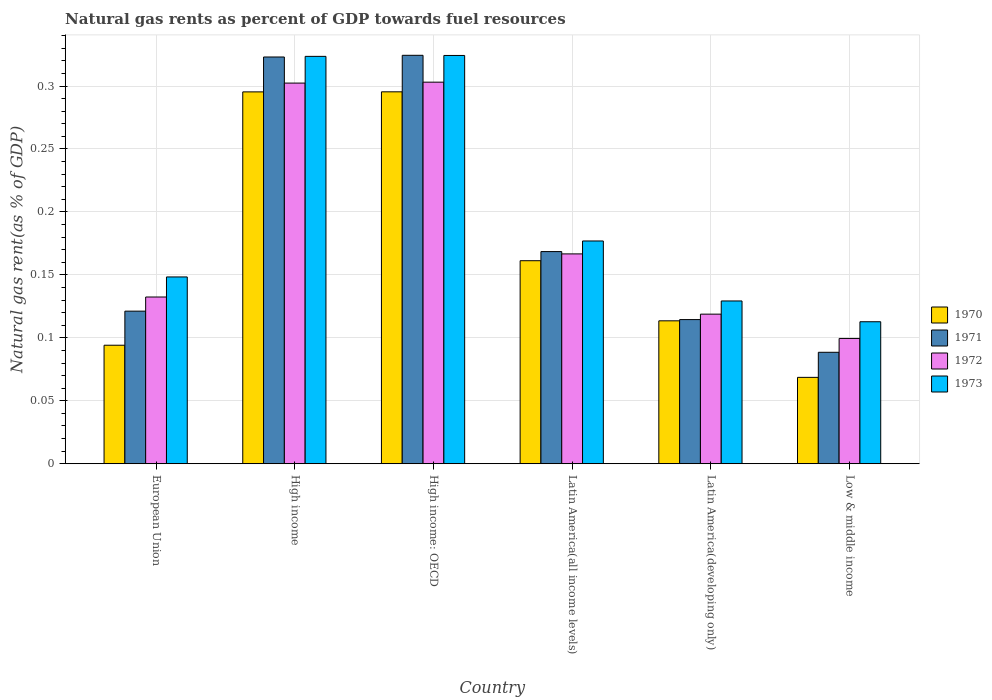How many different coloured bars are there?
Your answer should be very brief. 4. Are the number of bars per tick equal to the number of legend labels?
Provide a succinct answer. Yes. How many bars are there on the 5th tick from the right?
Make the answer very short. 4. In how many cases, is the number of bars for a given country not equal to the number of legend labels?
Offer a terse response. 0. What is the natural gas rent in 1970 in Latin America(all income levels)?
Your answer should be compact. 0.16. Across all countries, what is the maximum natural gas rent in 1971?
Give a very brief answer. 0.32. Across all countries, what is the minimum natural gas rent in 1971?
Your response must be concise. 0.09. In which country was the natural gas rent in 1973 maximum?
Give a very brief answer. High income: OECD. What is the total natural gas rent in 1970 in the graph?
Offer a terse response. 1.03. What is the difference between the natural gas rent in 1971 in Latin America(all income levels) and that in Low & middle income?
Ensure brevity in your answer.  0.08. What is the difference between the natural gas rent in 1972 in Latin America(all income levels) and the natural gas rent in 1973 in European Union?
Your response must be concise. 0.02. What is the average natural gas rent in 1971 per country?
Your response must be concise. 0.19. What is the difference between the natural gas rent of/in 1970 and natural gas rent of/in 1971 in Low & middle income?
Offer a terse response. -0.02. In how many countries, is the natural gas rent in 1971 greater than 0.17 %?
Your response must be concise. 2. What is the ratio of the natural gas rent in 1971 in European Union to that in Latin America(all income levels)?
Offer a terse response. 0.72. Is the difference between the natural gas rent in 1970 in High income: OECD and Latin America(developing only) greater than the difference between the natural gas rent in 1971 in High income: OECD and Latin America(developing only)?
Your answer should be very brief. No. What is the difference between the highest and the second highest natural gas rent in 1972?
Keep it short and to the point. 0. What is the difference between the highest and the lowest natural gas rent in 1973?
Provide a short and direct response. 0.21. In how many countries, is the natural gas rent in 1970 greater than the average natural gas rent in 1970 taken over all countries?
Ensure brevity in your answer.  2. Is it the case that in every country, the sum of the natural gas rent in 1973 and natural gas rent in 1970 is greater than the sum of natural gas rent in 1972 and natural gas rent in 1971?
Your response must be concise. No. What does the 2nd bar from the left in Latin America(all income levels) represents?
Provide a succinct answer. 1971. Is it the case that in every country, the sum of the natural gas rent in 1973 and natural gas rent in 1970 is greater than the natural gas rent in 1971?
Ensure brevity in your answer.  Yes. How many bars are there?
Ensure brevity in your answer.  24. How many countries are there in the graph?
Offer a terse response. 6. What is the difference between two consecutive major ticks on the Y-axis?
Provide a succinct answer. 0.05. Does the graph contain any zero values?
Provide a succinct answer. No. Does the graph contain grids?
Your answer should be compact. Yes. How are the legend labels stacked?
Your answer should be very brief. Vertical. What is the title of the graph?
Provide a succinct answer. Natural gas rents as percent of GDP towards fuel resources. Does "1967" appear as one of the legend labels in the graph?
Give a very brief answer. No. What is the label or title of the X-axis?
Your response must be concise. Country. What is the label or title of the Y-axis?
Offer a very short reply. Natural gas rent(as % of GDP). What is the Natural gas rent(as % of GDP) in 1970 in European Union?
Provide a short and direct response. 0.09. What is the Natural gas rent(as % of GDP) of 1971 in European Union?
Ensure brevity in your answer.  0.12. What is the Natural gas rent(as % of GDP) in 1972 in European Union?
Provide a short and direct response. 0.13. What is the Natural gas rent(as % of GDP) of 1973 in European Union?
Give a very brief answer. 0.15. What is the Natural gas rent(as % of GDP) of 1970 in High income?
Your answer should be very brief. 0.3. What is the Natural gas rent(as % of GDP) of 1971 in High income?
Offer a terse response. 0.32. What is the Natural gas rent(as % of GDP) in 1972 in High income?
Provide a short and direct response. 0.3. What is the Natural gas rent(as % of GDP) of 1973 in High income?
Offer a very short reply. 0.32. What is the Natural gas rent(as % of GDP) of 1970 in High income: OECD?
Offer a very short reply. 0.3. What is the Natural gas rent(as % of GDP) of 1971 in High income: OECD?
Provide a succinct answer. 0.32. What is the Natural gas rent(as % of GDP) in 1972 in High income: OECD?
Provide a succinct answer. 0.3. What is the Natural gas rent(as % of GDP) of 1973 in High income: OECD?
Your response must be concise. 0.32. What is the Natural gas rent(as % of GDP) in 1970 in Latin America(all income levels)?
Provide a succinct answer. 0.16. What is the Natural gas rent(as % of GDP) of 1971 in Latin America(all income levels)?
Your answer should be compact. 0.17. What is the Natural gas rent(as % of GDP) in 1972 in Latin America(all income levels)?
Keep it short and to the point. 0.17. What is the Natural gas rent(as % of GDP) of 1973 in Latin America(all income levels)?
Your answer should be compact. 0.18. What is the Natural gas rent(as % of GDP) in 1970 in Latin America(developing only)?
Offer a very short reply. 0.11. What is the Natural gas rent(as % of GDP) of 1971 in Latin America(developing only)?
Offer a very short reply. 0.11. What is the Natural gas rent(as % of GDP) in 1972 in Latin America(developing only)?
Offer a terse response. 0.12. What is the Natural gas rent(as % of GDP) in 1973 in Latin America(developing only)?
Provide a short and direct response. 0.13. What is the Natural gas rent(as % of GDP) of 1970 in Low & middle income?
Your response must be concise. 0.07. What is the Natural gas rent(as % of GDP) in 1971 in Low & middle income?
Make the answer very short. 0.09. What is the Natural gas rent(as % of GDP) of 1972 in Low & middle income?
Ensure brevity in your answer.  0.1. What is the Natural gas rent(as % of GDP) of 1973 in Low & middle income?
Provide a short and direct response. 0.11. Across all countries, what is the maximum Natural gas rent(as % of GDP) in 1970?
Offer a very short reply. 0.3. Across all countries, what is the maximum Natural gas rent(as % of GDP) in 1971?
Your answer should be very brief. 0.32. Across all countries, what is the maximum Natural gas rent(as % of GDP) in 1972?
Ensure brevity in your answer.  0.3. Across all countries, what is the maximum Natural gas rent(as % of GDP) in 1973?
Give a very brief answer. 0.32. Across all countries, what is the minimum Natural gas rent(as % of GDP) of 1970?
Provide a succinct answer. 0.07. Across all countries, what is the minimum Natural gas rent(as % of GDP) of 1971?
Your response must be concise. 0.09. Across all countries, what is the minimum Natural gas rent(as % of GDP) in 1972?
Offer a terse response. 0.1. Across all countries, what is the minimum Natural gas rent(as % of GDP) in 1973?
Give a very brief answer. 0.11. What is the total Natural gas rent(as % of GDP) of 1970 in the graph?
Provide a short and direct response. 1.03. What is the total Natural gas rent(as % of GDP) in 1971 in the graph?
Provide a short and direct response. 1.14. What is the total Natural gas rent(as % of GDP) in 1972 in the graph?
Keep it short and to the point. 1.12. What is the total Natural gas rent(as % of GDP) of 1973 in the graph?
Ensure brevity in your answer.  1.22. What is the difference between the Natural gas rent(as % of GDP) in 1970 in European Union and that in High income?
Ensure brevity in your answer.  -0.2. What is the difference between the Natural gas rent(as % of GDP) in 1971 in European Union and that in High income?
Provide a short and direct response. -0.2. What is the difference between the Natural gas rent(as % of GDP) of 1972 in European Union and that in High income?
Your response must be concise. -0.17. What is the difference between the Natural gas rent(as % of GDP) of 1973 in European Union and that in High income?
Make the answer very short. -0.18. What is the difference between the Natural gas rent(as % of GDP) of 1970 in European Union and that in High income: OECD?
Provide a succinct answer. -0.2. What is the difference between the Natural gas rent(as % of GDP) of 1971 in European Union and that in High income: OECD?
Provide a short and direct response. -0.2. What is the difference between the Natural gas rent(as % of GDP) of 1972 in European Union and that in High income: OECD?
Offer a terse response. -0.17. What is the difference between the Natural gas rent(as % of GDP) of 1973 in European Union and that in High income: OECD?
Your response must be concise. -0.18. What is the difference between the Natural gas rent(as % of GDP) of 1970 in European Union and that in Latin America(all income levels)?
Provide a short and direct response. -0.07. What is the difference between the Natural gas rent(as % of GDP) of 1971 in European Union and that in Latin America(all income levels)?
Provide a short and direct response. -0.05. What is the difference between the Natural gas rent(as % of GDP) of 1972 in European Union and that in Latin America(all income levels)?
Provide a short and direct response. -0.03. What is the difference between the Natural gas rent(as % of GDP) in 1973 in European Union and that in Latin America(all income levels)?
Your answer should be very brief. -0.03. What is the difference between the Natural gas rent(as % of GDP) in 1970 in European Union and that in Latin America(developing only)?
Provide a short and direct response. -0.02. What is the difference between the Natural gas rent(as % of GDP) in 1971 in European Union and that in Latin America(developing only)?
Keep it short and to the point. 0.01. What is the difference between the Natural gas rent(as % of GDP) in 1972 in European Union and that in Latin America(developing only)?
Your answer should be compact. 0.01. What is the difference between the Natural gas rent(as % of GDP) in 1973 in European Union and that in Latin America(developing only)?
Your answer should be compact. 0.02. What is the difference between the Natural gas rent(as % of GDP) of 1970 in European Union and that in Low & middle income?
Your response must be concise. 0.03. What is the difference between the Natural gas rent(as % of GDP) in 1971 in European Union and that in Low & middle income?
Make the answer very short. 0.03. What is the difference between the Natural gas rent(as % of GDP) of 1972 in European Union and that in Low & middle income?
Your response must be concise. 0.03. What is the difference between the Natural gas rent(as % of GDP) in 1973 in European Union and that in Low & middle income?
Provide a succinct answer. 0.04. What is the difference between the Natural gas rent(as % of GDP) in 1970 in High income and that in High income: OECD?
Keep it short and to the point. -0. What is the difference between the Natural gas rent(as % of GDP) of 1971 in High income and that in High income: OECD?
Your response must be concise. -0. What is the difference between the Natural gas rent(as % of GDP) in 1972 in High income and that in High income: OECD?
Ensure brevity in your answer.  -0. What is the difference between the Natural gas rent(as % of GDP) in 1973 in High income and that in High income: OECD?
Your response must be concise. -0. What is the difference between the Natural gas rent(as % of GDP) in 1970 in High income and that in Latin America(all income levels)?
Provide a short and direct response. 0.13. What is the difference between the Natural gas rent(as % of GDP) of 1971 in High income and that in Latin America(all income levels)?
Keep it short and to the point. 0.15. What is the difference between the Natural gas rent(as % of GDP) in 1972 in High income and that in Latin America(all income levels)?
Offer a very short reply. 0.14. What is the difference between the Natural gas rent(as % of GDP) in 1973 in High income and that in Latin America(all income levels)?
Offer a very short reply. 0.15. What is the difference between the Natural gas rent(as % of GDP) in 1970 in High income and that in Latin America(developing only)?
Ensure brevity in your answer.  0.18. What is the difference between the Natural gas rent(as % of GDP) of 1971 in High income and that in Latin America(developing only)?
Keep it short and to the point. 0.21. What is the difference between the Natural gas rent(as % of GDP) in 1972 in High income and that in Latin America(developing only)?
Provide a short and direct response. 0.18. What is the difference between the Natural gas rent(as % of GDP) of 1973 in High income and that in Latin America(developing only)?
Keep it short and to the point. 0.19. What is the difference between the Natural gas rent(as % of GDP) of 1970 in High income and that in Low & middle income?
Your answer should be very brief. 0.23. What is the difference between the Natural gas rent(as % of GDP) in 1971 in High income and that in Low & middle income?
Your answer should be compact. 0.23. What is the difference between the Natural gas rent(as % of GDP) in 1972 in High income and that in Low & middle income?
Your answer should be compact. 0.2. What is the difference between the Natural gas rent(as % of GDP) of 1973 in High income and that in Low & middle income?
Your answer should be very brief. 0.21. What is the difference between the Natural gas rent(as % of GDP) of 1970 in High income: OECD and that in Latin America(all income levels)?
Your answer should be compact. 0.13. What is the difference between the Natural gas rent(as % of GDP) in 1971 in High income: OECD and that in Latin America(all income levels)?
Make the answer very short. 0.16. What is the difference between the Natural gas rent(as % of GDP) in 1972 in High income: OECD and that in Latin America(all income levels)?
Keep it short and to the point. 0.14. What is the difference between the Natural gas rent(as % of GDP) in 1973 in High income: OECD and that in Latin America(all income levels)?
Your answer should be very brief. 0.15. What is the difference between the Natural gas rent(as % of GDP) of 1970 in High income: OECD and that in Latin America(developing only)?
Provide a short and direct response. 0.18. What is the difference between the Natural gas rent(as % of GDP) in 1971 in High income: OECD and that in Latin America(developing only)?
Offer a very short reply. 0.21. What is the difference between the Natural gas rent(as % of GDP) of 1972 in High income: OECD and that in Latin America(developing only)?
Make the answer very short. 0.18. What is the difference between the Natural gas rent(as % of GDP) of 1973 in High income: OECD and that in Latin America(developing only)?
Your answer should be very brief. 0.2. What is the difference between the Natural gas rent(as % of GDP) of 1970 in High income: OECD and that in Low & middle income?
Make the answer very short. 0.23. What is the difference between the Natural gas rent(as % of GDP) in 1971 in High income: OECD and that in Low & middle income?
Give a very brief answer. 0.24. What is the difference between the Natural gas rent(as % of GDP) in 1972 in High income: OECD and that in Low & middle income?
Offer a terse response. 0.2. What is the difference between the Natural gas rent(as % of GDP) of 1973 in High income: OECD and that in Low & middle income?
Your answer should be very brief. 0.21. What is the difference between the Natural gas rent(as % of GDP) in 1970 in Latin America(all income levels) and that in Latin America(developing only)?
Ensure brevity in your answer.  0.05. What is the difference between the Natural gas rent(as % of GDP) in 1971 in Latin America(all income levels) and that in Latin America(developing only)?
Ensure brevity in your answer.  0.05. What is the difference between the Natural gas rent(as % of GDP) in 1972 in Latin America(all income levels) and that in Latin America(developing only)?
Make the answer very short. 0.05. What is the difference between the Natural gas rent(as % of GDP) in 1973 in Latin America(all income levels) and that in Latin America(developing only)?
Your answer should be very brief. 0.05. What is the difference between the Natural gas rent(as % of GDP) of 1970 in Latin America(all income levels) and that in Low & middle income?
Offer a terse response. 0.09. What is the difference between the Natural gas rent(as % of GDP) of 1971 in Latin America(all income levels) and that in Low & middle income?
Offer a terse response. 0.08. What is the difference between the Natural gas rent(as % of GDP) of 1972 in Latin America(all income levels) and that in Low & middle income?
Your answer should be very brief. 0.07. What is the difference between the Natural gas rent(as % of GDP) of 1973 in Latin America(all income levels) and that in Low & middle income?
Provide a short and direct response. 0.06. What is the difference between the Natural gas rent(as % of GDP) in 1970 in Latin America(developing only) and that in Low & middle income?
Provide a short and direct response. 0.04. What is the difference between the Natural gas rent(as % of GDP) of 1971 in Latin America(developing only) and that in Low & middle income?
Your answer should be very brief. 0.03. What is the difference between the Natural gas rent(as % of GDP) of 1972 in Latin America(developing only) and that in Low & middle income?
Make the answer very short. 0.02. What is the difference between the Natural gas rent(as % of GDP) of 1973 in Latin America(developing only) and that in Low & middle income?
Give a very brief answer. 0.02. What is the difference between the Natural gas rent(as % of GDP) in 1970 in European Union and the Natural gas rent(as % of GDP) in 1971 in High income?
Keep it short and to the point. -0.23. What is the difference between the Natural gas rent(as % of GDP) of 1970 in European Union and the Natural gas rent(as % of GDP) of 1972 in High income?
Your answer should be compact. -0.21. What is the difference between the Natural gas rent(as % of GDP) in 1970 in European Union and the Natural gas rent(as % of GDP) in 1973 in High income?
Give a very brief answer. -0.23. What is the difference between the Natural gas rent(as % of GDP) in 1971 in European Union and the Natural gas rent(as % of GDP) in 1972 in High income?
Provide a succinct answer. -0.18. What is the difference between the Natural gas rent(as % of GDP) in 1971 in European Union and the Natural gas rent(as % of GDP) in 1973 in High income?
Ensure brevity in your answer.  -0.2. What is the difference between the Natural gas rent(as % of GDP) in 1972 in European Union and the Natural gas rent(as % of GDP) in 1973 in High income?
Make the answer very short. -0.19. What is the difference between the Natural gas rent(as % of GDP) of 1970 in European Union and the Natural gas rent(as % of GDP) of 1971 in High income: OECD?
Keep it short and to the point. -0.23. What is the difference between the Natural gas rent(as % of GDP) of 1970 in European Union and the Natural gas rent(as % of GDP) of 1972 in High income: OECD?
Your answer should be very brief. -0.21. What is the difference between the Natural gas rent(as % of GDP) in 1970 in European Union and the Natural gas rent(as % of GDP) in 1973 in High income: OECD?
Provide a short and direct response. -0.23. What is the difference between the Natural gas rent(as % of GDP) in 1971 in European Union and the Natural gas rent(as % of GDP) in 1972 in High income: OECD?
Ensure brevity in your answer.  -0.18. What is the difference between the Natural gas rent(as % of GDP) in 1971 in European Union and the Natural gas rent(as % of GDP) in 1973 in High income: OECD?
Offer a very short reply. -0.2. What is the difference between the Natural gas rent(as % of GDP) in 1972 in European Union and the Natural gas rent(as % of GDP) in 1973 in High income: OECD?
Give a very brief answer. -0.19. What is the difference between the Natural gas rent(as % of GDP) of 1970 in European Union and the Natural gas rent(as % of GDP) of 1971 in Latin America(all income levels)?
Offer a terse response. -0.07. What is the difference between the Natural gas rent(as % of GDP) of 1970 in European Union and the Natural gas rent(as % of GDP) of 1972 in Latin America(all income levels)?
Offer a very short reply. -0.07. What is the difference between the Natural gas rent(as % of GDP) of 1970 in European Union and the Natural gas rent(as % of GDP) of 1973 in Latin America(all income levels)?
Ensure brevity in your answer.  -0.08. What is the difference between the Natural gas rent(as % of GDP) in 1971 in European Union and the Natural gas rent(as % of GDP) in 1972 in Latin America(all income levels)?
Your answer should be very brief. -0.05. What is the difference between the Natural gas rent(as % of GDP) in 1971 in European Union and the Natural gas rent(as % of GDP) in 1973 in Latin America(all income levels)?
Your answer should be compact. -0.06. What is the difference between the Natural gas rent(as % of GDP) in 1972 in European Union and the Natural gas rent(as % of GDP) in 1973 in Latin America(all income levels)?
Provide a succinct answer. -0.04. What is the difference between the Natural gas rent(as % of GDP) of 1970 in European Union and the Natural gas rent(as % of GDP) of 1971 in Latin America(developing only)?
Provide a succinct answer. -0.02. What is the difference between the Natural gas rent(as % of GDP) of 1970 in European Union and the Natural gas rent(as % of GDP) of 1972 in Latin America(developing only)?
Your answer should be compact. -0.02. What is the difference between the Natural gas rent(as % of GDP) of 1970 in European Union and the Natural gas rent(as % of GDP) of 1973 in Latin America(developing only)?
Ensure brevity in your answer.  -0.04. What is the difference between the Natural gas rent(as % of GDP) in 1971 in European Union and the Natural gas rent(as % of GDP) in 1972 in Latin America(developing only)?
Offer a terse response. 0. What is the difference between the Natural gas rent(as % of GDP) in 1971 in European Union and the Natural gas rent(as % of GDP) in 1973 in Latin America(developing only)?
Give a very brief answer. -0.01. What is the difference between the Natural gas rent(as % of GDP) of 1972 in European Union and the Natural gas rent(as % of GDP) of 1973 in Latin America(developing only)?
Make the answer very short. 0. What is the difference between the Natural gas rent(as % of GDP) in 1970 in European Union and the Natural gas rent(as % of GDP) in 1971 in Low & middle income?
Give a very brief answer. 0.01. What is the difference between the Natural gas rent(as % of GDP) of 1970 in European Union and the Natural gas rent(as % of GDP) of 1972 in Low & middle income?
Provide a short and direct response. -0.01. What is the difference between the Natural gas rent(as % of GDP) of 1970 in European Union and the Natural gas rent(as % of GDP) of 1973 in Low & middle income?
Offer a very short reply. -0.02. What is the difference between the Natural gas rent(as % of GDP) of 1971 in European Union and the Natural gas rent(as % of GDP) of 1972 in Low & middle income?
Give a very brief answer. 0.02. What is the difference between the Natural gas rent(as % of GDP) in 1971 in European Union and the Natural gas rent(as % of GDP) in 1973 in Low & middle income?
Offer a very short reply. 0.01. What is the difference between the Natural gas rent(as % of GDP) in 1972 in European Union and the Natural gas rent(as % of GDP) in 1973 in Low & middle income?
Offer a terse response. 0.02. What is the difference between the Natural gas rent(as % of GDP) in 1970 in High income and the Natural gas rent(as % of GDP) in 1971 in High income: OECD?
Your answer should be compact. -0.03. What is the difference between the Natural gas rent(as % of GDP) of 1970 in High income and the Natural gas rent(as % of GDP) of 1972 in High income: OECD?
Give a very brief answer. -0.01. What is the difference between the Natural gas rent(as % of GDP) of 1970 in High income and the Natural gas rent(as % of GDP) of 1973 in High income: OECD?
Your answer should be compact. -0.03. What is the difference between the Natural gas rent(as % of GDP) in 1971 in High income and the Natural gas rent(as % of GDP) in 1973 in High income: OECD?
Offer a terse response. -0. What is the difference between the Natural gas rent(as % of GDP) of 1972 in High income and the Natural gas rent(as % of GDP) of 1973 in High income: OECD?
Keep it short and to the point. -0.02. What is the difference between the Natural gas rent(as % of GDP) of 1970 in High income and the Natural gas rent(as % of GDP) of 1971 in Latin America(all income levels)?
Offer a very short reply. 0.13. What is the difference between the Natural gas rent(as % of GDP) in 1970 in High income and the Natural gas rent(as % of GDP) in 1972 in Latin America(all income levels)?
Provide a short and direct response. 0.13. What is the difference between the Natural gas rent(as % of GDP) in 1970 in High income and the Natural gas rent(as % of GDP) in 1973 in Latin America(all income levels)?
Make the answer very short. 0.12. What is the difference between the Natural gas rent(as % of GDP) in 1971 in High income and the Natural gas rent(as % of GDP) in 1972 in Latin America(all income levels)?
Ensure brevity in your answer.  0.16. What is the difference between the Natural gas rent(as % of GDP) in 1971 in High income and the Natural gas rent(as % of GDP) in 1973 in Latin America(all income levels)?
Give a very brief answer. 0.15. What is the difference between the Natural gas rent(as % of GDP) in 1972 in High income and the Natural gas rent(as % of GDP) in 1973 in Latin America(all income levels)?
Give a very brief answer. 0.13. What is the difference between the Natural gas rent(as % of GDP) of 1970 in High income and the Natural gas rent(as % of GDP) of 1971 in Latin America(developing only)?
Give a very brief answer. 0.18. What is the difference between the Natural gas rent(as % of GDP) of 1970 in High income and the Natural gas rent(as % of GDP) of 1972 in Latin America(developing only)?
Provide a succinct answer. 0.18. What is the difference between the Natural gas rent(as % of GDP) in 1970 in High income and the Natural gas rent(as % of GDP) in 1973 in Latin America(developing only)?
Provide a short and direct response. 0.17. What is the difference between the Natural gas rent(as % of GDP) in 1971 in High income and the Natural gas rent(as % of GDP) in 1972 in Latin America(developing only)?
Keep it short and to the point. 0.2. What is the difference between the Natural gas rent(as % of GDP) in 1971 in High income and the Natural gas rent(as % of GDP) in 1973 in Latin America(developing only)?
Your response must be concise. 0.19. What is the difference between the Natural gas rent(as % of GDP) in 1972 in High income and the Natural gas rent(as % of GDP) in 1973 in Latin America(developing only)?
Ensure brevity in your answer.  0.17. What is the difference between the Natural gas rent(as % of GDP) in 1970 in High income and the Natural gas rent(as % of GDP) in 1971 in Low & middle income?
Your answer should be compact. 0.21. What is the difference between the Natural gas rent(as % of GDP) of 1970 in High income and the Natural gas rent(as % of GDP) of 1972 in Low & middle income?
Ensure brevity in your answer.  0.2. What is the difference between the Natural gas rent(as % of GDP) in 1970 in High income and the Natural gas rent(as % of GDP) in 1973 in Low & middle income?
Provide a succinct answer. 0.18. What is the difference between the Natural gas rent(as % of GDP) of 1971 in High income and the Natural gas rent(as % of GDP) of 1972 in Low & middle income?
Your response must be concise. 0.22. What is the difference between the Natural gas rent(as % of GDP) in 1971 in High income and the Natural gas rent(as % of GDP) in 1973 in Low & middle income?
Your answer should be very brief. 0.21. What is the difference between the Natural gas rent(as % of GDP) in 1972 in High income and the Natural gas rent(as % of GDP) in 1973 in Low & middle income?
Give a very brief answer. 0.19. What is the difference between the Natural gas rent(as % of GDP) of 1970 in High income: OECD and the Natural gas rent(as % of GDP) of 1971 in Latin America(all income levels)?
Offer a very short reply. 0.13. What is the difference between the Natural gas rent(as % of GDP) in 1970 in High income: OECD and the Natural gas rent(as % of GDP) in 1972 in Latin America(all income levels)?
Keep it short and to the point. 0.13. What is the difference between the Natural gas rent(as % of GDP) of 1970 in High income: OECD and the Natural gas rent(as % of GDP) of 1973 in Latin America(all income levels)?
Offer a terse response. 0.12. What is the difference between the Natural gas rent(as % of GDP) of 1971 in High income: OECD and the Natural gas rent(as % of GDP) of 1972 in Latin America(all income levels)?
Offer a very short reply. 0.16. What is the difference between the Natural gas rent(as % of GDP) of 1971 in High income: OECD and the Natural gas rent(as % of GDP) of 1973 in Latin America(all income levels)?
Keep it short and to the point. 0.15. What is the difference between the Natural gas rent(as % of GDP) of 1972 in High income: OECD and the Natural gas rent(as % of GDP) of 1973 in Latin America(all income levels)?
Your answer should be very brief. 0.13. What is the difference between the Natural gas rent(as % of GDP) of 1970 in High income: OECD and the Natural gas rent(as % of GDP) of 1971 in Latin America(developing only)?
Provide a succinct answer. 0.18. What is the difference between the Natural gas rent(as % of GDP) in 1970 in High income: OECD and the Natural gas rent(as % of GDP) in 1972 in Latin America(developing only)?
Keep it short and to the point. 0.18. What is the difference between the Natural gas rent(as % of GDP) of 1970 in High income: OECD and the Natural gas rent(as % of GDP) of 1973 in Latin America(developing only)?
Your answer should be compact. 0.17. What is the difference between the Natural gas rent(as % of GDP) in 1971 in High income: OECD and the Natural gas rent(as % of GDP) in 1972 in Latin America(developing only)?
Your answer should be very brief. 0.21. What is the difference between the Natural gas rent(as % of GDP) in 1971 in High income: OECD and the Natural gas rent(as % of GDP) in 1973 in Latin America(developing only)?
Provide a short and direct response. 0.2. What is the difference between the Natural gas rent(as % of GDP) in 1972 in High income: OECD and the Natural gas rent(as % of GDP) in 1973 in Latin America(developing only)?
Offer a terse response. 0.17. What is the difference between the Natural gas rent(as % of GDP) in 1970 in High income: OECD and the Natural gas rent(as % of GDP) in 1971 in Low & middle income?
Offer a very short reply. 0.21. What is the difference between the Natural gas rent(as % of GDP) of 1970 in High income: OECD and the Natural gas rent(as % of GDP) of 1972 in Low & middle income?
Provide a short and direct response. 0.2. What is the difference between the Natural gas rent(as % of GDP) in 1970 in High income: OECD and the Natural gas rent(as % of GDP) in 1973 in Low & middle income?
Give a very brief answer. 0.18. What is the difference between the Natural gas rent(as % of GDP) of 1971 in High income: OECD and the Natural gas rent(as % of GDP) of 1972 in Low & middle income?
Your answer should be very brief. 0.22. What is the difference between the Natural gas rent(as % of GDP) in 1971 in High income: OECD and the Natural gas rent(as % of GDP) in 1973 in Low & middle income?
Provide a succinct answer. 0.21. What is the difference between the Natural gas rent(as % of GDP) in 1972 in High income: OECD and the Natural gas rent(as % of GDP) in 1973 in Low & middle income?
Make the answer very short. 0.19. What is the difference between the Natural gas rent(as % of GDP) of 1970 in Latin America(all income levels) and the Natural gas rent(as % of GDP) of 1971 in Latin America(developing only)?
Your response must be concise. 0.05. What is the difference between the Natural gas rent(as % of GDP) in 1970 in Latin America(all income levels) and the Natural gas rent(as % of GDP) in 1972 in Latin America(developing only)?
Give a very brief answer. 0.04. What is the difference between the Natural gas rent(as % of GDP) of 1970 in Latin America(all income levels) and the Natural gas rent(as % of GDP) of 1973 in Latin America(developing only)?
Provide a succinct answer. 0.03. What is the difference between the Natural gas rent(as % of GDP) in 1971 in Latin America(all income levels) and the Natural gas rent(as % of GDP) in 1972 in Latin America(developing only)?
Offer a terse response. 0.05. What is the difference between the Natural gas rent(as % of GDP) in 1971 in Latin America(all income levels) and the Natural gas rent(as % of GDP) in 1973 in Latin America(developing only)?
Your answer should be compact. 0.04. What is the difference between the Natural gas rent(as % of GDP) of 1972 in Latin America(all income levels) and the Natural gas rent(as % of GDP) of 1973 in Latin America(developing only)?
Offer a terse response. 0.04. What is the difference between the Natural gas rent(as % of GDP) of 1970 in Latin America(all income levels) and the Natural gas rent(as % of GDP) of 1971 in Low & middle income?
Provide a succinct answer. 0.07. What is the difference between the Natural gas rent(as % of GDP) of 1970 in Latin America(all income levels) and the Natural gas rent(as % of GDP) of 1972 in Low & middle income?
Your answer should be compact. 0.06. What is the difference between the Natural gas rent(as % of GDP) of 1970 in Latin America(all income levels) and the Natural gas rent(as % of GDP) of 1973 in Low & middle income?
Keep it short and to the point. 0.05. What is the difference between the Natural gas rent(as % of GDP) in 1971 in Latin America(all income levels) and the Natural gas rent(as % of GDP) in 1972 in Low & middle income?
Your answer should be very brief. 0.07. What is the difference between the Natural gas rent(as % of GDP) of 1971 in Latin America(all income levels) and the Natural gas rent(as % of GDP) of 1973 in Low & middle income?
Provide a succinct answer. 0.06. What is the difference between the Natural gas rent(as % of GDP) in 1972 in Latin America(all income levels) and the Natural gas rent(as % of GDP) in 1973 in Low & middle income?
Provide a short and direct response. 0.05. What is the difference between the Natural gas rent(as % of GDP) of 1970 in Latin America(developing only) and the Natural gas rent(as % of GDP) of 1971 in Low & middle income?
Your answer should be very brief. 0.03. What is the difference between the Natural gas rent(as % of GDP) in 1970 in Latin America(developing only) and the Natural gas rent(as % of GDP) in 1972 in Low & middle income?
Provide a succinct answer. 0.01. What is the difference between the Natural gas rent(as % of GDP) of 1970 in Latin America(developing only) and the Natural gas rent(as % of GDP) of 1973 in Low & middle income?
Your response must be concise. 0. What is the difference between the Natural gas rent(as % of GDP) in 1971 in Latin America(developing only) and the Natural gas rent(as % of GDP) in 1972 in Low & middle income?
Your response must be concise. 0.01. What is the difference between the Natural gas rent(as % of GDP) in 1971 in Latin America(developing only) and the Natural gas rent(as % of GDP) in 1973 in Low & middle income?
Your answer should be compact. 0. What is the difference between the Natural gas rent(as % of GDP) of 1972 in Latin America(developing only) and the Natural gas rent(as % of GDP) of 1973 in Low & middle income?
Make the answer very short. 0.01. What is the average Natural gas rent(as % of GDP) of 1970 per country?
Offer a terse response. 0.17. What is the average Natural gas rent(as % of GDP) of 1971 per country?
Your answer should be compact. 0.19. What is the average Natural gas rent(as % of GDP) in 1972 per country?
Ensure brevity in your answer.  0.19. What is the average Natural gas rent(as % of GDP) of 1973 per country?
Keep it short and to the point. 0.2. What is the difference between the Natural gas rent(as % of GDP) in 1970 and Natural gas rent(as % of GDP) in 1971 in European Union?
Provide a succinct answer. -0.03. What is the difference between the Natural gas rent(as % of GDP) of 1970 and Natural gas rent(as % of GDP) of 1972 in European Union?
Provide a short and direct response. -0.04. What is the difference between the Natural gas rent(as % of GDP) of 1970 and Natural gas rent(as % of GDP) of 1973 in European Union?
Provide a short and direct response. -0.05. What is the difference between the Natural gas rent(as % of GDP) of 1971 and Natural gas rent(as % of GDP) of 1972 in European Union?
Provide a short and direct response. -0.01. What is the difference between the Natural gas rent(as % of GDP) of 1971 and Natural gas rent(as % of GDP) of 1973 in European Union?
Make the answer very short. -0.03. What is the difference between the Natural gas rent(as % of GDP) of 1972 and Natural gas rent(as % of GDP) of 1973 in European Union?
Offer a very short reply. -0.02. What is the difference between the Natural gas rent(as % of GDP) in 1970 and Natural gas rent(as % of GDP) in 1971 in High income?
Ensure brevity in your answer.  -0.03. What is the difference between the Natural gas rent(as % of GDP) in 1970 and Natural gas rent(as % of GDP) in 1972 in High income?
Provide a short and direct response. -0.01. What is the difference between the Natural gas rent(as % of GDP) in 1970 and Natural gas rent(as % of GDP) in 1973 in High income?
Offer a terse response. -0.03. What is the difference between the Natural gas rent(as % of GDP) of 1971 and Natural gas rent(as % of GDP) of 1972 in High income?
Keep it short and to the point. 0.02. What is the difference between the Natural gas rent(as % of GDP) of 1971 and Natural gas rent(as % of GDP) of 1973 in High income?
Your answer should be very brief. -0. What is the difference between the Natural gas rent(as % of GDP) of 1972 and Natural gas rent(as % of GDP) of 1973 in High income?
Offer a very short reply. -0.02. What is the difference between the Natural gas rent(as % of GDP) of 1970 and Natural gas rent(as % of GDP) of 1971 in High income: OECD?
Give a very brief answer. -0.03. What is the difference between the Natural gas rent(as % of GDP) in 1970 and Natural gas rent(as % of GDP) in 1972 in High income: OECD?
Provide a succinct answer. -0.01. What is the difference between the Natural gas rent(as % of GDP) in 1970 and Natural gas rent(as % of GDP) in 1973 in High income: OECD?
Your answer should be very brief. -0.03. What is the difference between the Natural gas rent(as % of GDP) in 1971 and Natural gas rent(as % of GDP) in 1972 in High income: OECD?
Your answer should be compact. 0.02. What is the difference between the Natural gas rent(as % of GDP) of 1971 and Natural gas rent(as % of GDP) of 1973 in High income: OECD?
Your answer should be compact. 0. What is the difference between the Natural gas rent(as % of GDP) of 1972 and Natural gas rent(as % of GDP) of 1973 in High income: OECD?
Your answer should be very brief. -0.02. What is the difference between the Natural gas rent(as % of GDP) of 1970 and Natural gas rent(as % of GDP) of 1971 in Latin America(all income levels)?
Offer a terse response. -0.01. What is the difference between the Natural gas rent(as % of GDP) in 1970 and Natural gas rent(as % of GDP) in 1972 in Latin America(all income levels)?
Ensure brevity in your answer.  -0.01. What is the difference between the Natural gas rent(as % of GDP) of 1970 and Natural gas rent(as % of GDP) of 1973 in Latin America(all income levels)?
Offer a very short reply. -0.02. What is the difference between the Natural gas rent(as % of GDP) of 1971 and Natural gas rent(as % of GDP) of 1972 in Latin America(all income levels)?
Offer a very short reply. 0. What is the difference between the Natural gas rent(as % of GDP) of 1971 and Natural gas rent(as % of GDP) of 1973 in Latin America(all income levels)?
Provide a succinct answer. -0.01. What is the difference between the Natural gas rent(as % of GDP) of 1972 and Natural gas rent(as % of GDP) of 1973 in Latin America(all income levels)?
Make the answer very short. -0.01. What is the difference between the Natural gas rent(as % of GDP) of 1970 and Natural gas rent(as % of GDP) of 1971 in Latin America(developing only)?
Your answer should be compact. -0. What is the difference between the Natural gas rent(as % of GDP) of 1970 and Natural gas rent(as % of GDP) of 1972 in Latin America(developing only)?
Your answer should be very brief. -0.01. What is the difference between the Natural gas rent(as % of GDP) in 1970 and Natural gas rent(as % of GDP) in 1973 in Latin America(developing only)?
Your answer should be compact. -0.02. What is the difference between the Natural gas rent(as % of GDP) in 1971 and Natural gas rent(as % of GDP) in 1972 in Latin America(developing only)?
Offer a terse response. -0. What is the difference between the Natural gas rent(as % of GDP) of 1971 and Natural gas rent(as % of GDP) of 1973 in Latin America(developing only)?
Give a very brief answer. -0.01. What is the difference between the Natural gas rent(as % of GDP) in 1972 and Natural gas rent(as % of GDP) in 1973 in Latin America(developing only)?
Ensure brevity in your answer.  -0.01. What is the difference between the Natural gas rent(as % of GDP) in 1970 and Natural gas rent(as % of GDP) in 1971 in Low & middle income?
Your answer should be very brief. -0.02. What is the difference between the Natural gas rent(as % of GDP) of 1970 and Natural gas rent(as % of GDP) of 1972 in Low & middle income?
Offer a terse response. -0.03. What is the difference between the Natural gas rent(as % of GDP) of 1970 and Natural gas rent(as % of GDP) of 1973 in Low & middle income?
Provide a succinct answer. -0.04. What is the difference between the Natural gas rent(as % of GDP) of 1971 and Natural gas rent(as % of GDP) of 1972 in Low & middle income?
Ensure brevity in your answer.  -0.01. What is the difference between the Natural gas rent(as % of GDP) in 1971 and Natural gas rent(as % of GDP) in 1973 in Low & middle income?
Make the answer very short. -0.02. What is the difference between the Natural gas rent(as % of GDP) in 1972 and Natural gas rent(as % of GDP) in 1973 in Low & middle income?
Offer a very short reply. -0.01. What is the ratio of the Natural gas rent(as % of GDP) in 1970 in European Union to that in High income?
Make the answer very short. 0.32. What is the ratio of the Natural gas rent(as % of GDP) in 1971 in European Union to that in High income?
Provide a succinct answer. 0.38. What is the ratio of the Natural gas rent(as % of GDP) of 1972 in European Union to that in High income?
Offer a terse response. 0.44. What is the ratio of the Natural gas rent(as % of GDP) in 1973 in European Union to that in High income?
Offer a very short reply. 0.46. What is the ratio of the Natural gas rent(as % of GDP) in 1970 in European Union to that in High income: OECD?
Provide a succinct answer. 0.32. What is the ratio of the Natural gas rent(as % of GDP) in 1971 in European Union to that in High income: OECD?
Make the answer very short. 0.37. What is the ratio of the Natural gas rent(as % of GDP) of 1972 in European Union to that in High income: OECD?
Your answer should be compact. 0.44. What is the ratio of the Natural gas rent(as % of GDP) of 1973 in European Union to that in High income: OECD?
Your answer should be compact. 0.46. What is the ratio of the Natural gas rent(as % of GDP) in 1970 in European Union to that in Latin America(all income levels)?
Ensure brevity in your answer.  0.58. What is the ratio of the Natural gas rent(as % of GDP) in 1971 in European Union to that in Latin America(all income levels)?
Offer a very short reply. 0.72. What is the ratio of the Natural gas rent(as % of GDP) in 1972 in European Union to that in Latin America(all income levels)?
Your response must be concise. 0.79. What is the ratio of the Natural gas rent(as % of GDP) in 1973 in European Union to that in Latin America(all income levels)?
Your answer should be very brief. 0.84. What is the ratio of the Natural gas rent(as % of GDP) in 1970 in European Union to that in Latin America(developing only)?
Make the answer very short. 0.83. What is the ratio of the Natural gas rent(as % of GDP) in 1971 in European Union to that in Latin America(developing only)?
Your response must be concise. 1.06. What is the ratio of the Natural gas rent(as % of GDP) in 1972 in European Union to that in Latin America(developing only)?
Offer a terse response. 1.11. What is the ratio of the Natural gas rent(as % of GDP) of 1973 in European Union to that in Latin America(developing only)?
Provide a succinct answer. 1.15. What is the ratio of the Natural gas rent(as % of GDP) of 1970 in European Union to that in Low & middle income?
Provide a short and direct response. 1.37. What is the ratio of the Natural gas rent(as % of GDP) in 1971 in European Union to that in Low & middle income?
Provide a succinct answer. 1.37. What is the ratio of the Natural gas rent(as % of GDP) of 1972 in European Union to that in Low & middle income?
Offer a terse response. 1.33. What is the ratio of the Natural gas rent(as % of GDP) of 1973 in European Union to that in Low & middle income?
Provide a succinct answer. 1.32. What is the ratio of the Natural gas rent(as % of GDP) of 1970 in High income to that in Latin America(all income levels)?
Offer a very short reply. 1.83. What is the ratio of the Natural gas rent(as % of GDP) of 1971 in High income to that in Latin America(all income levels)?
Provide a short and direct response. 1.92. What is the ratio of the Natural gas rent(as % of GDP) of 1972 in High income to that in Latin America(all income levels)?
Ensure brevity in your answer.  1.81. What is the ratio of the Natural gas rent(as % of GDP) of 1973 in High income to that in Latin America(all income levels)?
Provide a short and direct response. 1.83. What is the ratio of the Natural gas rent(as % of GDP) of 1970 in High income to that in Latin America(developing only)?
Offer a very short reply. 2.6. What is the ratio of the Natural gas rent(as % of GDP) in 1971 in High income to that in Latin America(developing only)?
Provide a succinct answer. 2.82. What is the ratio of the Natural gas rent(as % of GDP) of 1972 in High income to that in Latin America(developing only)?
Keep it short and to the point. 2.54. What is the ratio of the Natural gas rent(as % of GDP) of 1973 in High income to that in Latin America(developing only)?
Give a very brief answer. 2.5. What is the ratio of the Natural gas rent(as % of GDP) in 1970 in High income to that in Low & middle income?
Your answer should be very brief. 4.31. What is the ratio of the Natural gas rent(as % of GDP) in 1971 in High income to that in Low & middle income?
Offer a terse response. 3.65. What is the ratio of the Natural gas rent(as % of GDP) of 1972 in High income to that in Low & middle income?
Make the answer very short. 3.04. What is the ratio of the Natural gas rent(as % of GDP) in 1973 in High income to that in Low & middle income?
Your response must be concise. 2.87. What is the ratio of the Natural gas rent(as % of GDP) of 1970 in High income: OECD to that in Latin America(all income levels)?
Keep it short and to the point. 1.83. What is the ratio of the Natural gas rent(as % of GDP) of 1971 in High income: OECD to that in Latin America(all income levels)?
Make the answer very short. 1.93. What is the ratio of the Natural gas rent(as % of GDP) in 1972 in High income: OECD to that in Latin America(all income levels)?
Make the answer very short. 1.82. What is the ratio of the Natural gas rent(as % of GDP) in 1973 in High income: OECD to that in Latin America(all income levels)?
Give a very brief answer. 1.83. What is the ratio of the Natural gas rent(as % of GDP) in 1970 in High income: OECD to that in Latin America(developing only)?
Keep it short and to the point. 2.6. What is the ratio of the Natural gas rent(as % of GDP) of 1971 in High income: OECD to that in Latin America(developing only)?
Give a very brief answer. 2.83. What is the ratio of the Natural gas rent(as % of GDP) in 1972 in High income: OECD to that in Latin America(developing only)?
Provide a short and direct response. 2.55. What is the ratio of the Natural gas rent(as % of GDP) of 1973 in High income: OECD to that in Latin America(developing only)?
Make the answer very short. 2.51. What is the ratio of the Natural gas rent(as % of GDP) in 1970 in High income: OECD to that in Low & middle income?
Your response must be concise. 4.31. What is the ratio of the Natural gas rent(as % of GDP) in 1971 in High income: OECD to that in Low & middle income?
Make the answer very short. 3.66. What is the ratio of the Natural gas rent(as % of GDP) in 1972 in High income: OECD to that in Low & middle income?
Give a very brief answer. 3.05. What is the ratio of the Natural gas rent(as % of GDP) of 1973 in High income: OECD to that in Low & middle income?
Your answer should be very brief. 2.88. What is the ratio of the Natural gas rent(as % of GDP) of 1970 in Latin America(all income levels) to that in Latin America(developing only)?
Your answer should be very brief. 1.42. What is the ratio of the Natural gas rent(as % of GDP) in 1971 in Latin America(all income levels) to that in Latin America(developing only)?
Offer a very short reply. 1.47. What is the ratio of the Natural gas rent(as % of GDP) in 1972 in Latin America(all income levels) to that in Latin America(developing only)?
Your answer should be very brief. 1.4. What is the ratio of the Natural gas rent(as % of GDP) of 1973 in Latin America(all income levels) to that in Latin America(developing only)?
Give a very brief answer. 1.37. What is the ratio of the Natural gas rent(as % of GDP) in 1970 in Latin America(all income levels) to that in Low & middle income?
Offer a very short reply. 2.35. What is the ratio of the Natural gas rent(as % of GDP) of 1971 in Latin America(all income levels) to that in Low & middle income?
Make the answer very short. 1.9. What is the ratio of the Natural gas rent(as % of GDP) of 1972 in Latin America(all income levels) to that in Low & middle income?
Provide a succinct answer. 1.67. What is the ratio of the Natural gas rent(as % of GDP) in 1973 in Latin America(all income levels) to that in Low & middle income?
Provide a short and direct response. 1.57. What is the ratio of the Natural gas rent(as % of GDP) in 1970 in Latin America(developing only) to that in Low & middle income?
Provide a short and direct response. 1.65. What is the ratio of the Natural gas rent(as % of GDP) in 1971 in Latin America(developing only) to that in Low & middle income?
Provide a short and direct response. 1.29. What is the ratio of the Natural gas rent(as % of GDP) in 1972 in Latin America(developing only) to that in Low & middle income?
Provide a short and direct response. 1.19. What is the ratio of the Natural gas rent(as % of GDP) of 1973 in Latin America(developing only) to that in Low & middle income?
Provide a short and direct response. 1.15. What is the difference between the highest and the second highest Natural gas rent(as % of GDP) of 1971?
Offer a terse response. 0. What is the difference between the highest and the second highest Natural gas rent(as % of GDP) in 1972?
Your response must be concise. 0. What is the difference between the highest and the second highest Natural gas rent(as % of GDP) of 1973?
Provide a succinct answer. 0. What is the difference between the highest and the lowest Natural gas rent(as % of GDP) in 1970?
Your response must be concise. 0.23. What is the difference between the highest and the lowest Natural gas rent(as % of GDP) in 1971?
Make the answer very short. 0.24. What is the difference between the highest and the lowest Natural gas rent(as % of GDP) in 1972?
Provide a short and direct response. 0.2. What is the difference between the highest and the lowest Natural gas rent(as % of GDP) in 1973?
Your answer should be very brief. 0.21. 